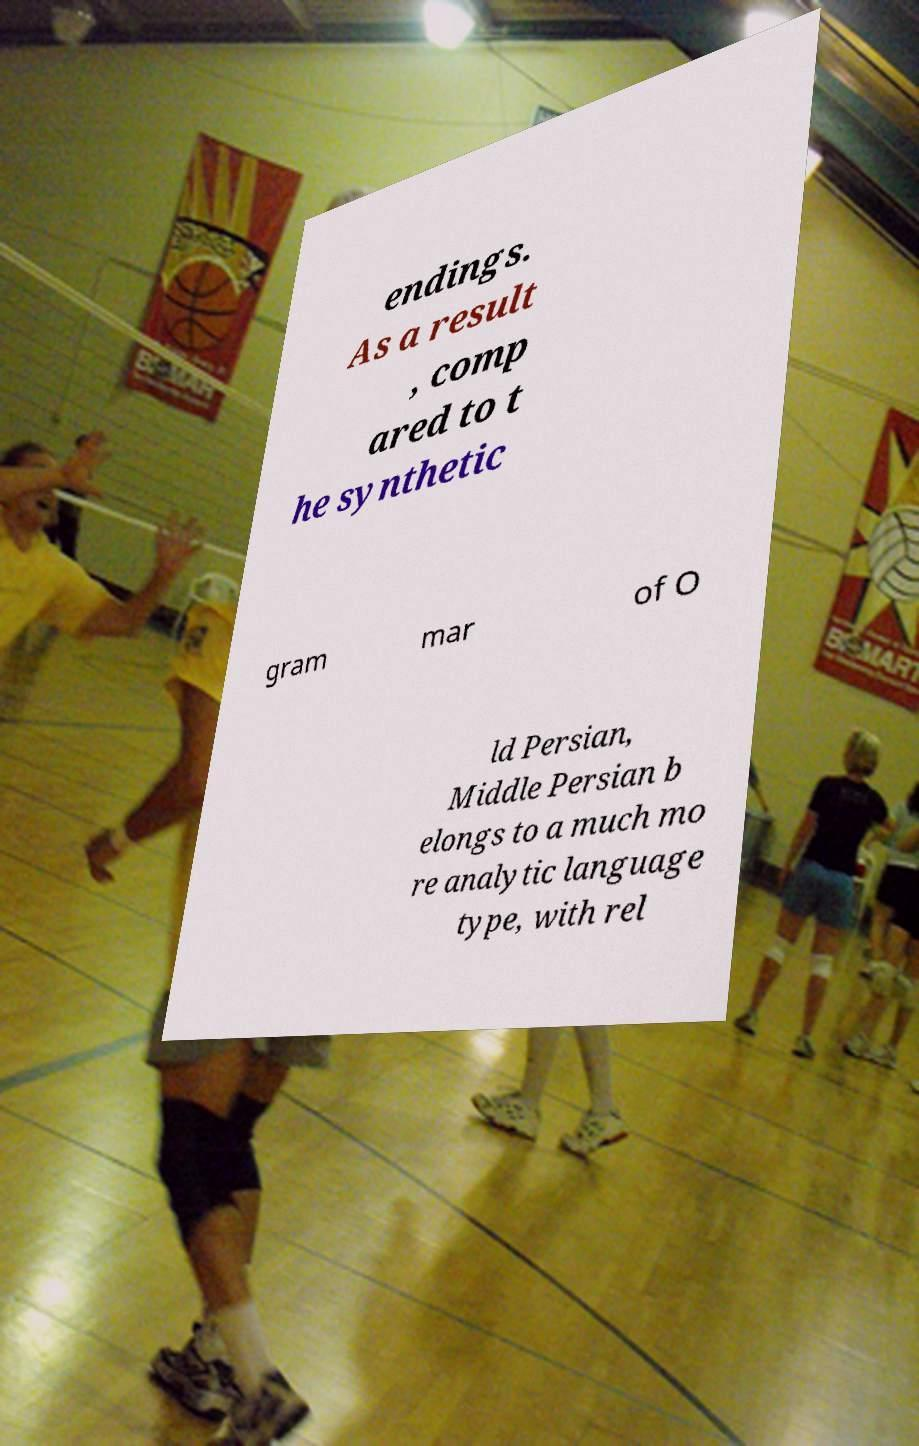Could you assist in decoding the text presented in this image and type it out clearly? endings. As a result , comp ared to t he synthetic gram mar of O ld Persian, Middle Persian b elongs to a much mo re analytic language type, with rel 